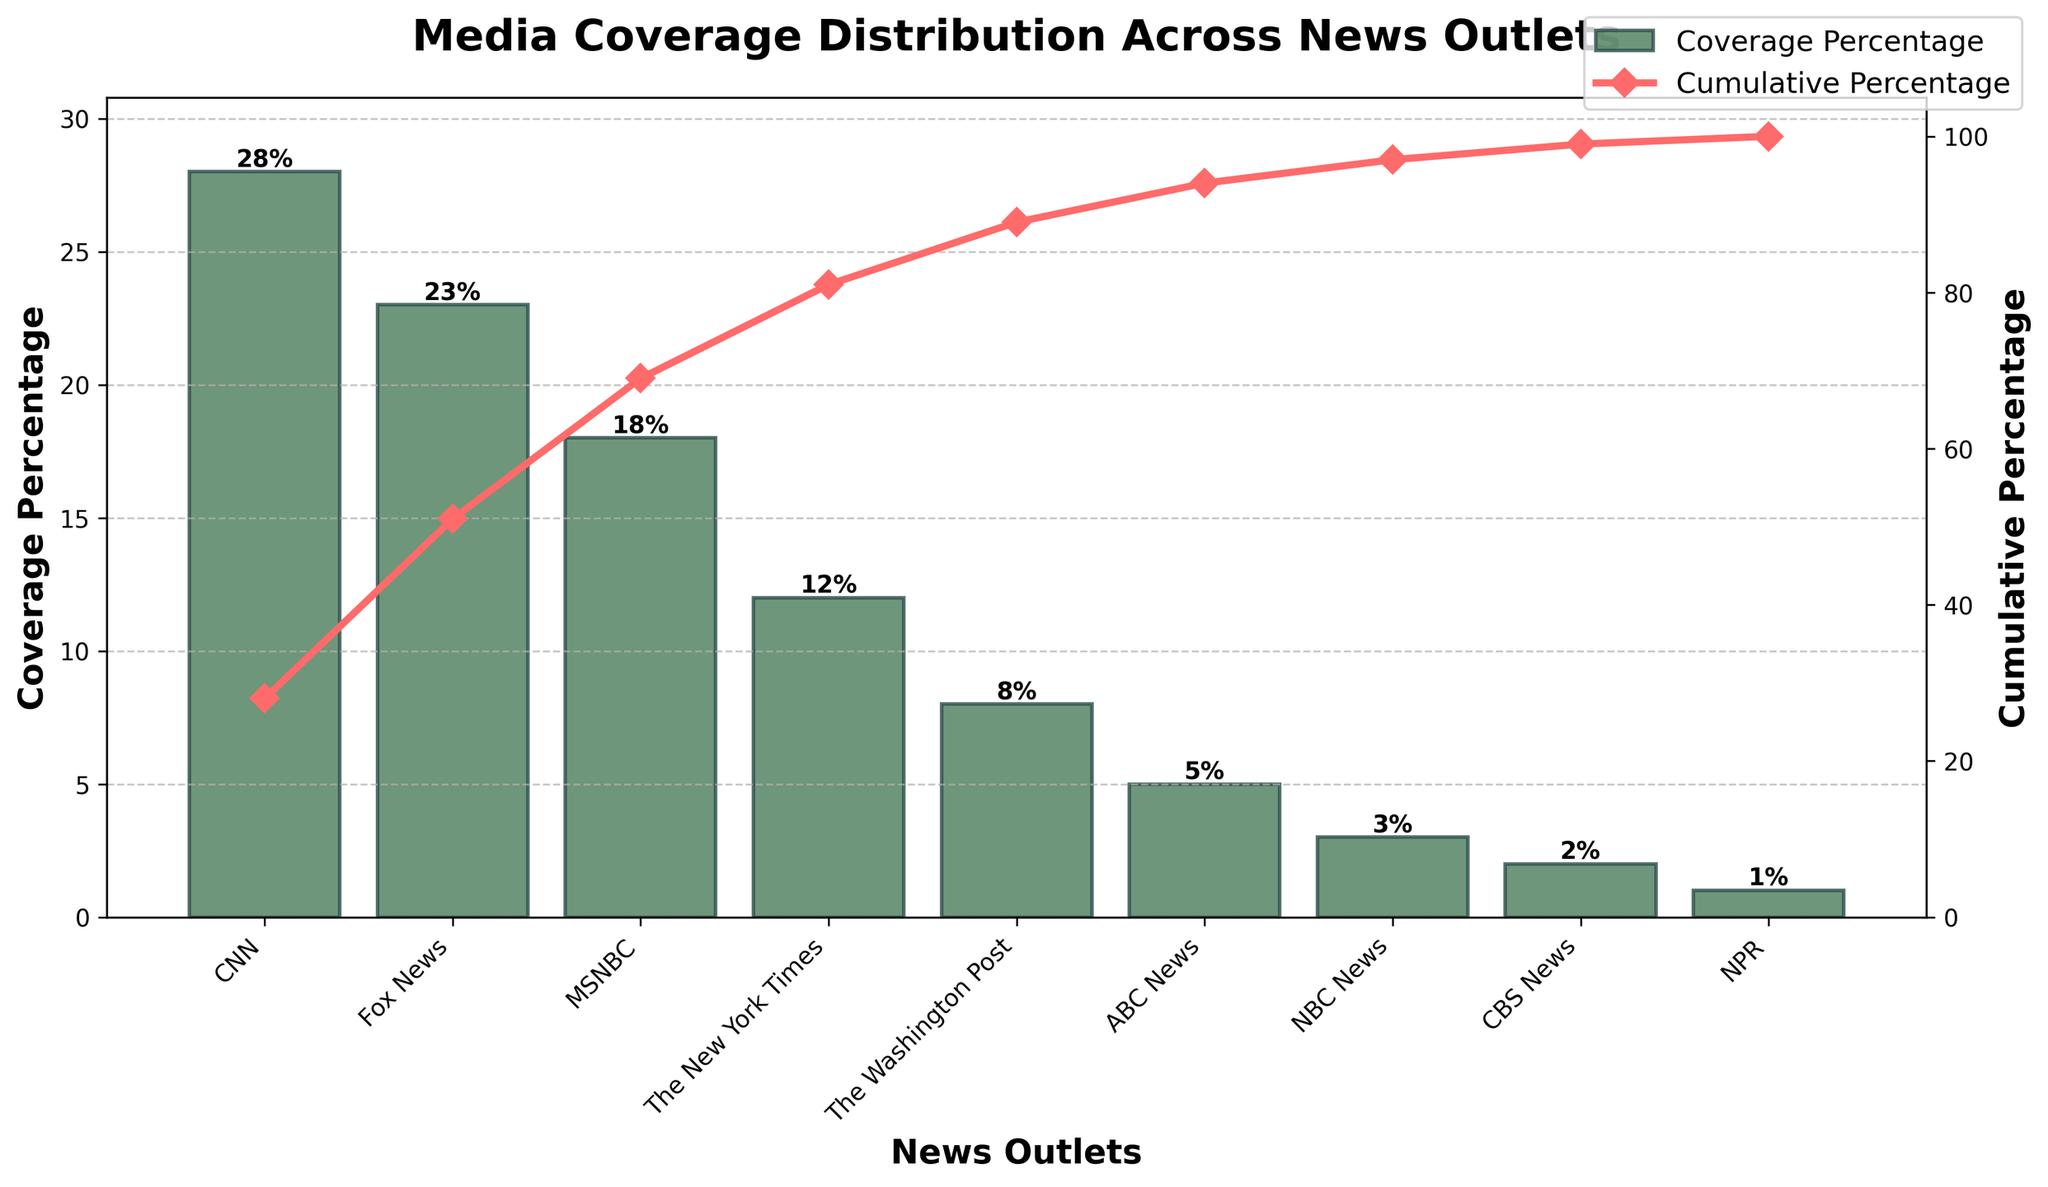what is the title of the chart? The title appears at the top of the chart and it is written in bold.
Answer: Media Coverage Distribution Across News Outlets How many news outlets are represented in the chart? By counting the bars on the x-axis, we can determine the number of news outlets represented.
Answer: 9 Which news outlet has the highest media coverage percentage? We look for the tallest bar which represents the highest coverage percentage.
Answer: CNN What is the cumulative percentage of media coverage up to MSNBC? Sum the coverage percentages of CNN, Fox News, and MSNBC, then divide by the total and convert to a cumulative percentage.
Answer: 69% How much more media coverage does CNN have compared to The New York Times? Subtract The New York Times' coverage percentage from CNN's coverage percentage.
Answer: 16% Which three outlets contribute to more than 50% of the total media coverage? Identify the outlets starting from the highest coverage, summing their percentages until it exceeds 50%.
Answer: CNN, Fox News, MSNBC What color is used to represent the bars in the bar chart? The color is visible to the eye and associated with the bars.
Answer: Dark Green What is the cumulative percentage at the point just after ABC News? Sum the coverage percentages of CNN, Fox News, MSNBC, The New York Times, The Washington Post, and ABC News, then convert to a cumulative percentage.
Answer: 94% Does ABC News receive more or less media coverage than NBC News? Compare the height of the bars representing ABC News and NBC News.
Answer: More What's the total media coverage percentage covered by the top four news outlets? Sum the percentages of CNN, Fox News, MSNBC, and The New York Times.
Answer: 81% 